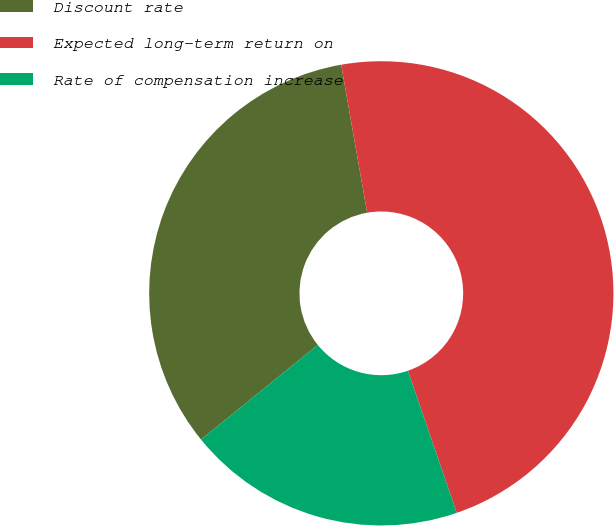<chart> <loc_0><loc_0><loc_500><loc_500><pie_chart><fcel>Discount rate<fcel>Expected long-term return on<fcel>Rate of compensation increase<nl><fcel>33.08%<fcel>47.5%<fcel>19.42%<nl></chart> 